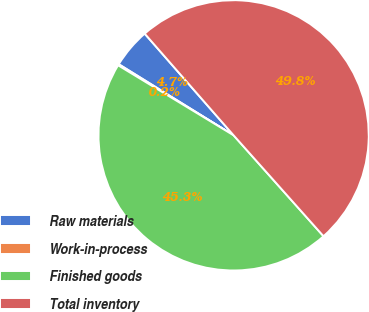Convert chart. <chart><loc_0><loc_0><loc_500><loc_500><pie_chart><fcel>Raw materials<fcel>Work-in-process<fcel>Finished goods<fcel>Total inventory<nl><fcel>4.74%<fcel>0.15%<fcel>45.26%<fcel>49.85%<nl></chart> 